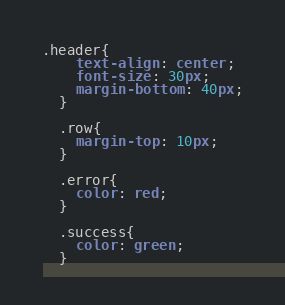<code> <loc_0><loc_0><loc_500><loc_500><_CSS_>.header{
    text-align: center;
    font-size: 30px;
    margin-bottom: 40px;
  }
  
  .row{
    margin-top: 10px;
  }
  
  .error{
    color: red;
  }
  
  .success{
    color: green;
  }</code> 